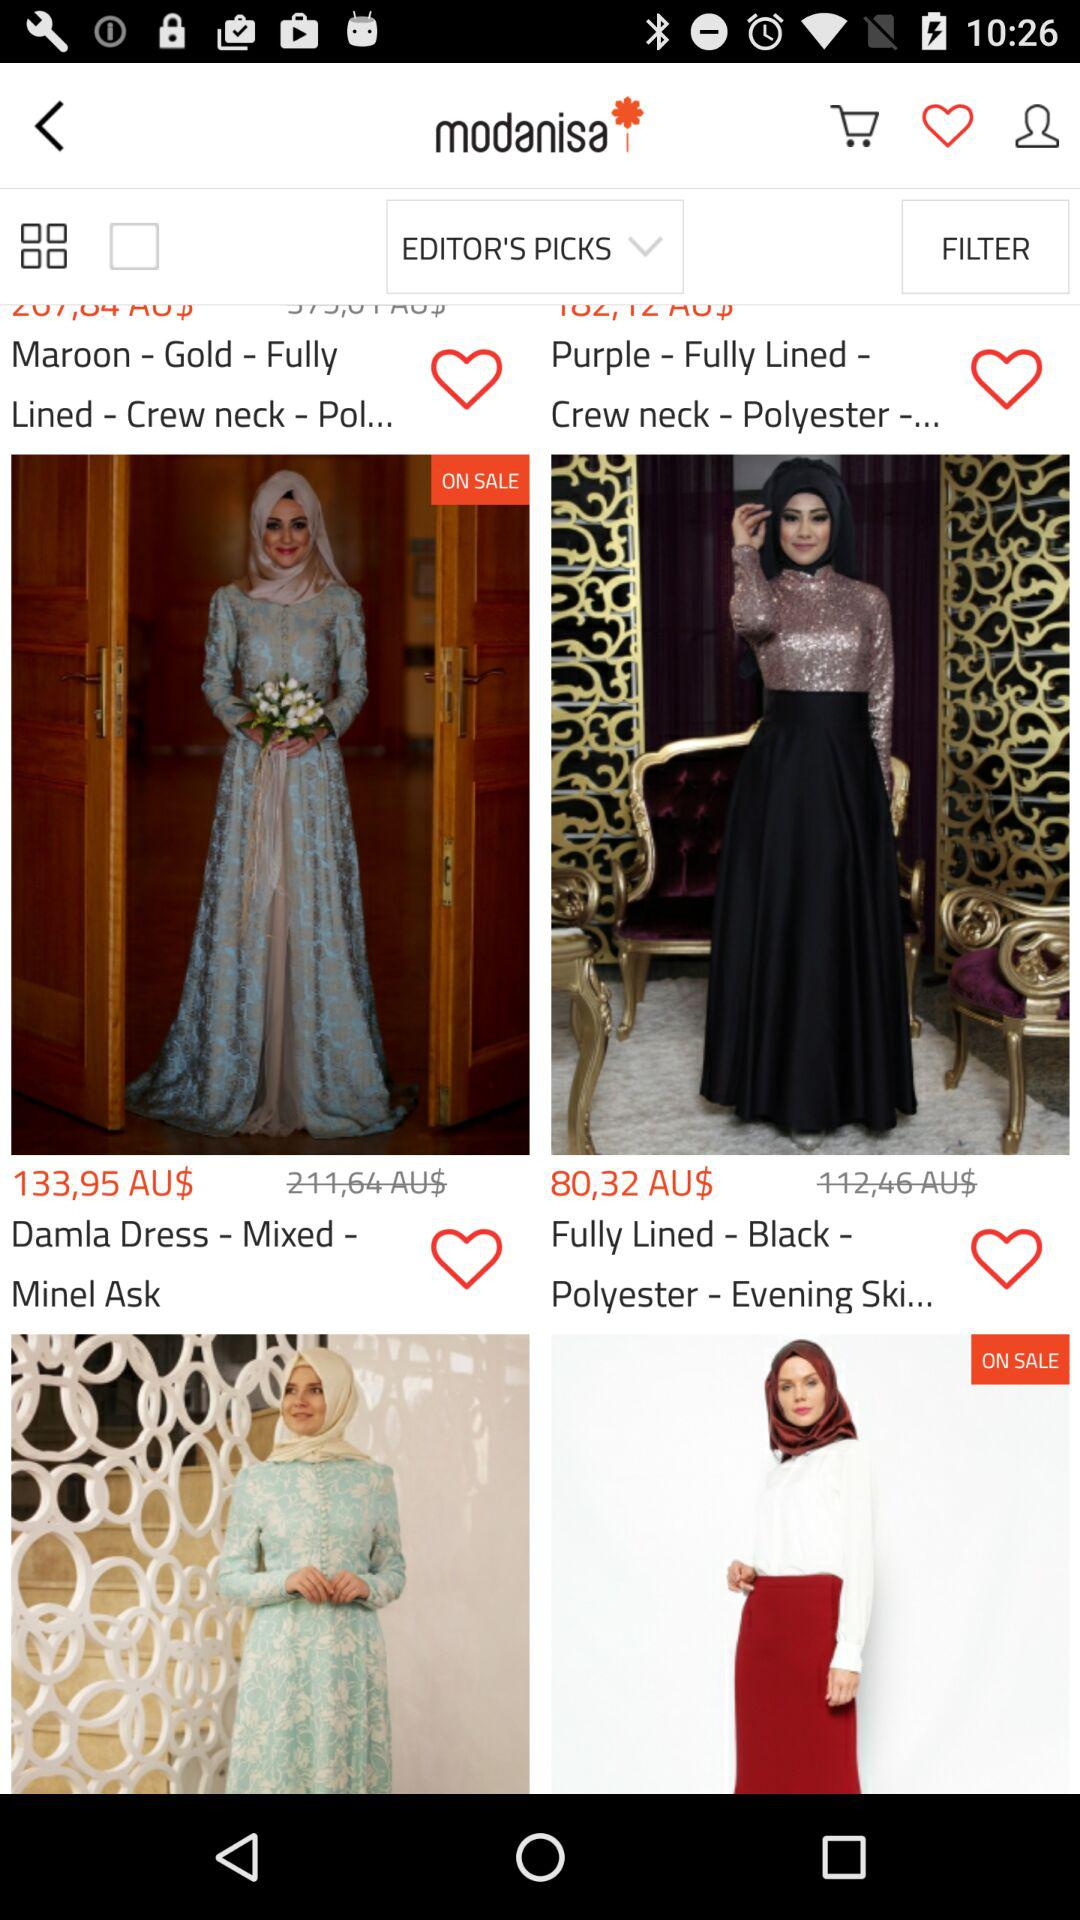Which color is available for the fully lined dress? The available colors are maroon-gold, purple and black. 